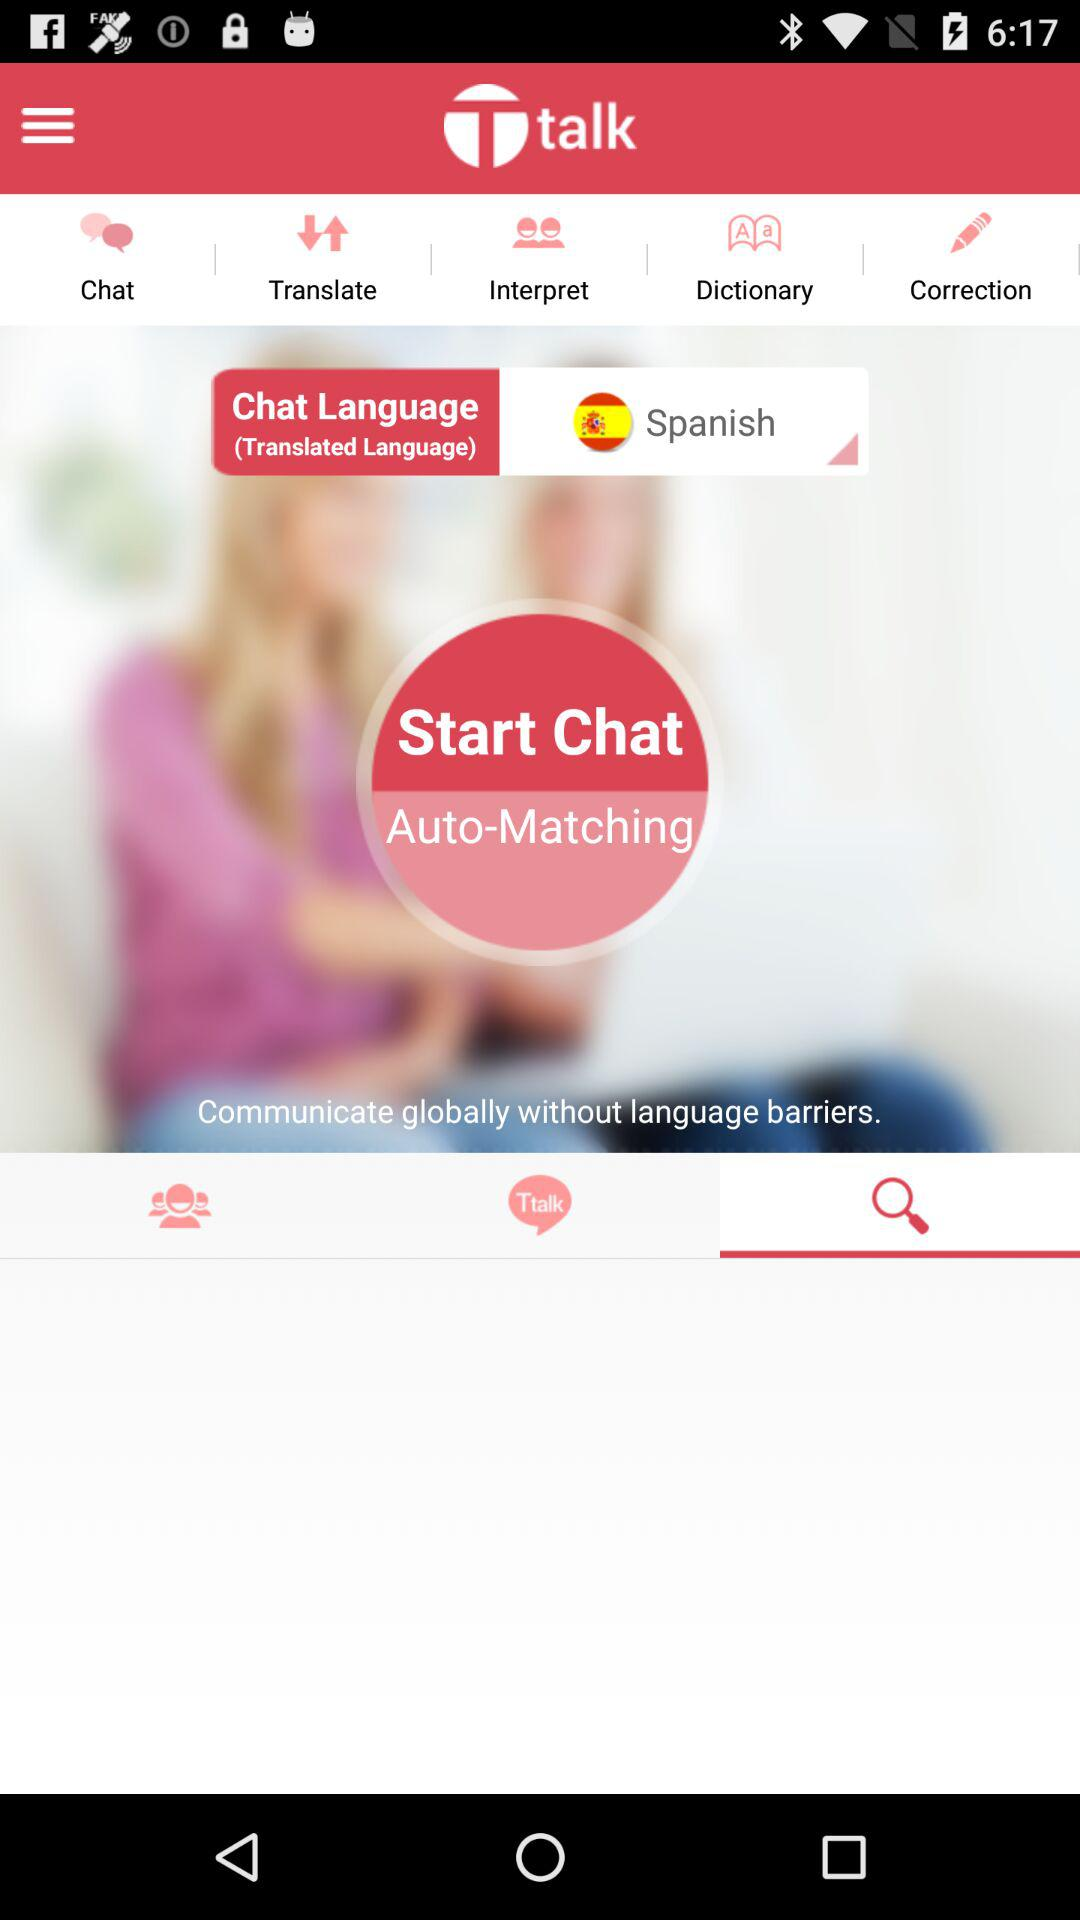What chat language has been chosen? The language is Spanish. 